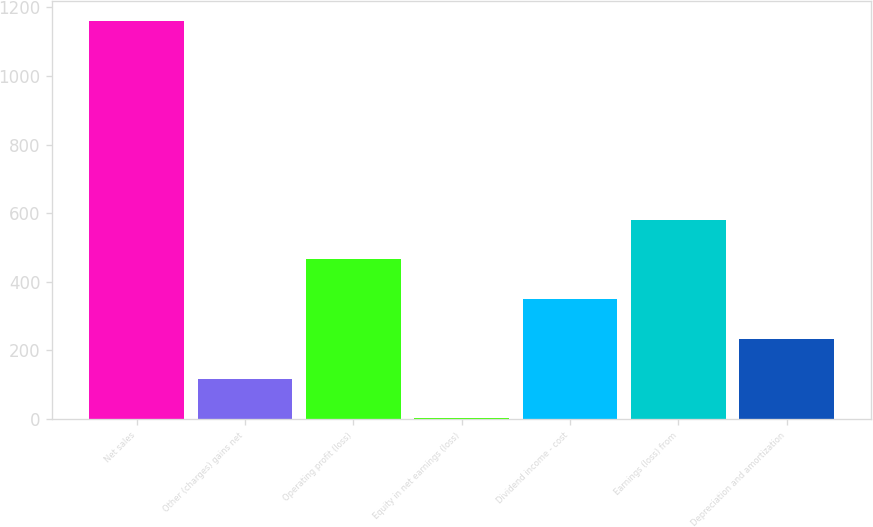Convert chart. <chart><loc_0><loc_0><loc_500><loc_500><bar_chart><fcel>Net sales<fcel>Other (charges) gains net<fcel>Operating profit (loss)<fcel>Equity in net earnings (loss)<fcel>Dividend income - cost<fcel>Earnings (loss) from<fcel>Depreciation and amortization<nl><fcel>1161<fcel>117.9<fcel>465.6<fcel>2<fcel>349.7<fcel>581.5<fcel>233.8<nl></chart> 